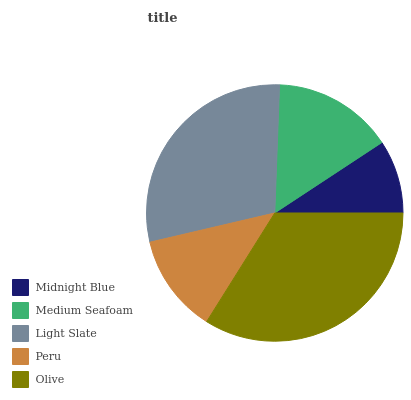Is Midnight Blue the minimum?
Answer yes or no. Yes. Is Olive the maximum?
Answer yes or no. Yes. Is Medium Seafoam the minimum?
Answer yes or no. No. Is Medium Seafoam the maximum?
Answer yes or no. No. Is Medium Seafoam greater than Midnight Blue?
Answer yes or no. Yes. Is Midnight Blue less than Medium Seafoam?
Answer yes or no. Yes. Is Midnight Blue greater than Medium Seafoam?
Answer yes or no. No. Is Medium Seafoam less than Midnight Blue?
Answer yes or no. No. Is Medium Seafoam the high median?
Answer yes or no. Yes. Is Medium Seafoam the low median?
Answer yes or no. Yes. Is Olive the high median?
Answer yes or no. No. Is Peru the low median?
Answer yes or no. No. 